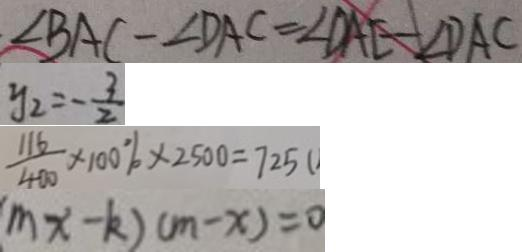<formula> <loc_0><loc_0><loc_500><loc_500>\angle B A C - \angle D A C = \angle D A E - \angle D A C 
 y _ { 2 } = - \frac { 3 } { 2 } 
 \frac { 1 1 6 } { 4 0 0 } \times 1 0 0 \% \times 2 5 0 0 = 7 2 5 
 m x - k ) ( m - x ) = 0</formula> 